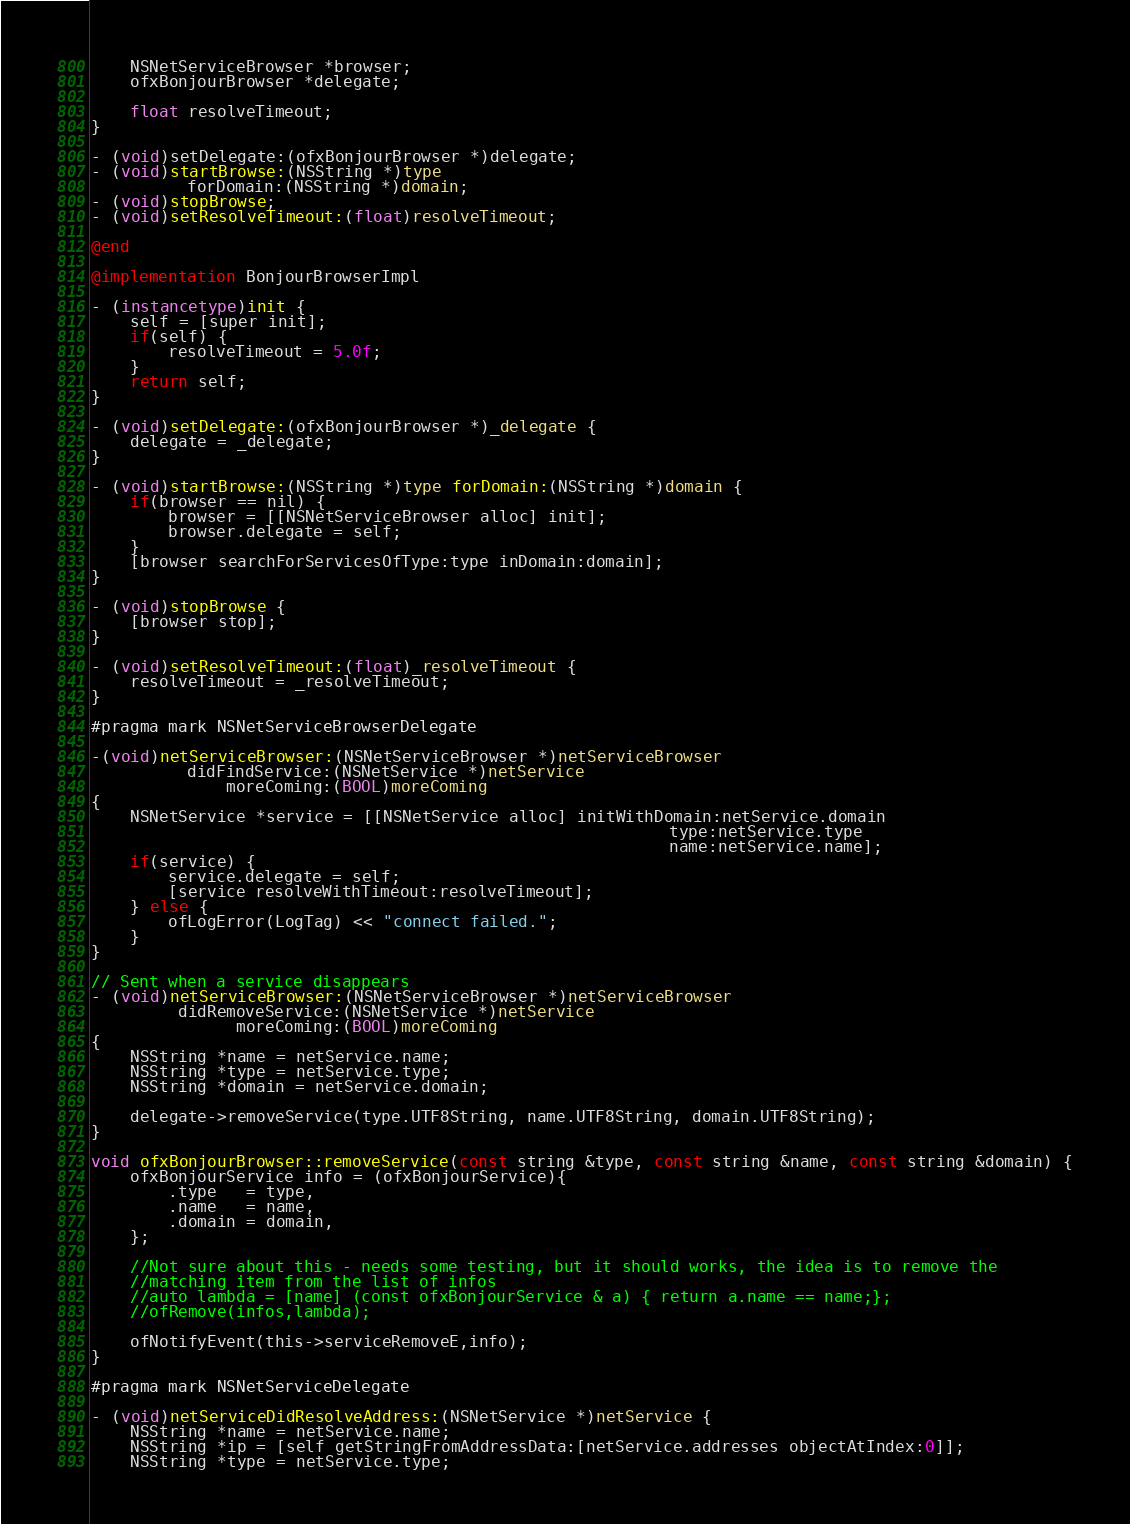Convert code to text. <code><loc_0><loc_0><loc_500><loc_500><_ObjectiveC_>    NSNetServiceBrowser *browser;
    ofxBonjourBrowser *delegate;
    
    float resolveTimeout;
}

- (void)setDelegate:(ofxBonjourBrowser *)delegate;
- (void)startBrowse:(NSString *)type
          forDomain:(NSString *)domain;
- (void)stopBrowse;
- (void)setResolveTimeout:(float)resolveTimeout;

@end

@implementation BonjourBrowserImpl

- (instancetype)init {
    self = [super init];
    if(self) {
        resolveTimeout = 5.0f;
    }
    return self;
}

- (void)setDelegate:(ofxBonjourBrowser *)_delegate {
    delegate = _delegate;
}

- (void)startBrowse:(NSString *)type forDomain:(NSString *)domain {
    if(browser == nil) {
        browser = [[NSNetServiceBrowser alloc] init];
        browser.delegate = self;
    }
    [browser searchForServicesOfType:type inDomain:domain];
}

- (void)stopBrowse {
    [browser stop];
}

- (void)setResolveTimeout:(float)_resolveTimeout {
    resolveTimeout = _resolveTimeout;
}

#pragma mark NSNetServiceBrowserDelegate

-(void)netServiceBrowser:(NSNetServiceBrowser *)netServiceBrowser
          didFindService:(NSNetService *)netService
              moreComing:(BOOL)moreComing
{
    NSNetService *service = [[NSNetService alloc] initWithDomain:netService.domain
                                                            type:netService.type
                                                            name:netService.name];
    if(service) {
        service.delegate = self;
        [service resolveWithTimeout:resolveTimeout];
    } else {
        ofLogError(LogTag) << "connect failed.";
    }
}

// Sent when a service disappears
- (void)netServiceBrowser:(NSNetServiceBrowser *)netServiceBrowser
         didRemoveService:(NSNetService *)netService
               moreComing:(BOOL)moreComing
{
    NSString *name = netService.name;
    NSString *type = netService.type;
    NSString *domain = netService.domain;
    
    delegate->removeService(type.UTF8String, name.UTF8String, domain.UTF8String);
}

void ofxBonjourBrowser::removeService(const string &type, const string &name, const string &domain) {
    ofxBonjourService info = (ofxBonjourService){
        .type   = type,
        .name   = name,
        .domain = domain,
    };
    
    //Not sure about this - needs some testing, but it should works, the idea is to remove the
    //matching item from the list of infos
    //auto lambda = [name] (const ofxBonjourService & a) { return a.name == name;};
    //ofRemove(infos,lambda);
    
    ofNotifyEvent(this->serviceRemoveE,info);
}

#pragma mark NSNetServiceDelegate

- (void)netServiceDidResolveAddress:(NSNetService *)netService {
    NSString *name = netService.name;
    NSString *ip = [self getStringFromAddressData:[netService.addresses objectAtIndex:0]];
    NSString *type = netService.type;</code> 